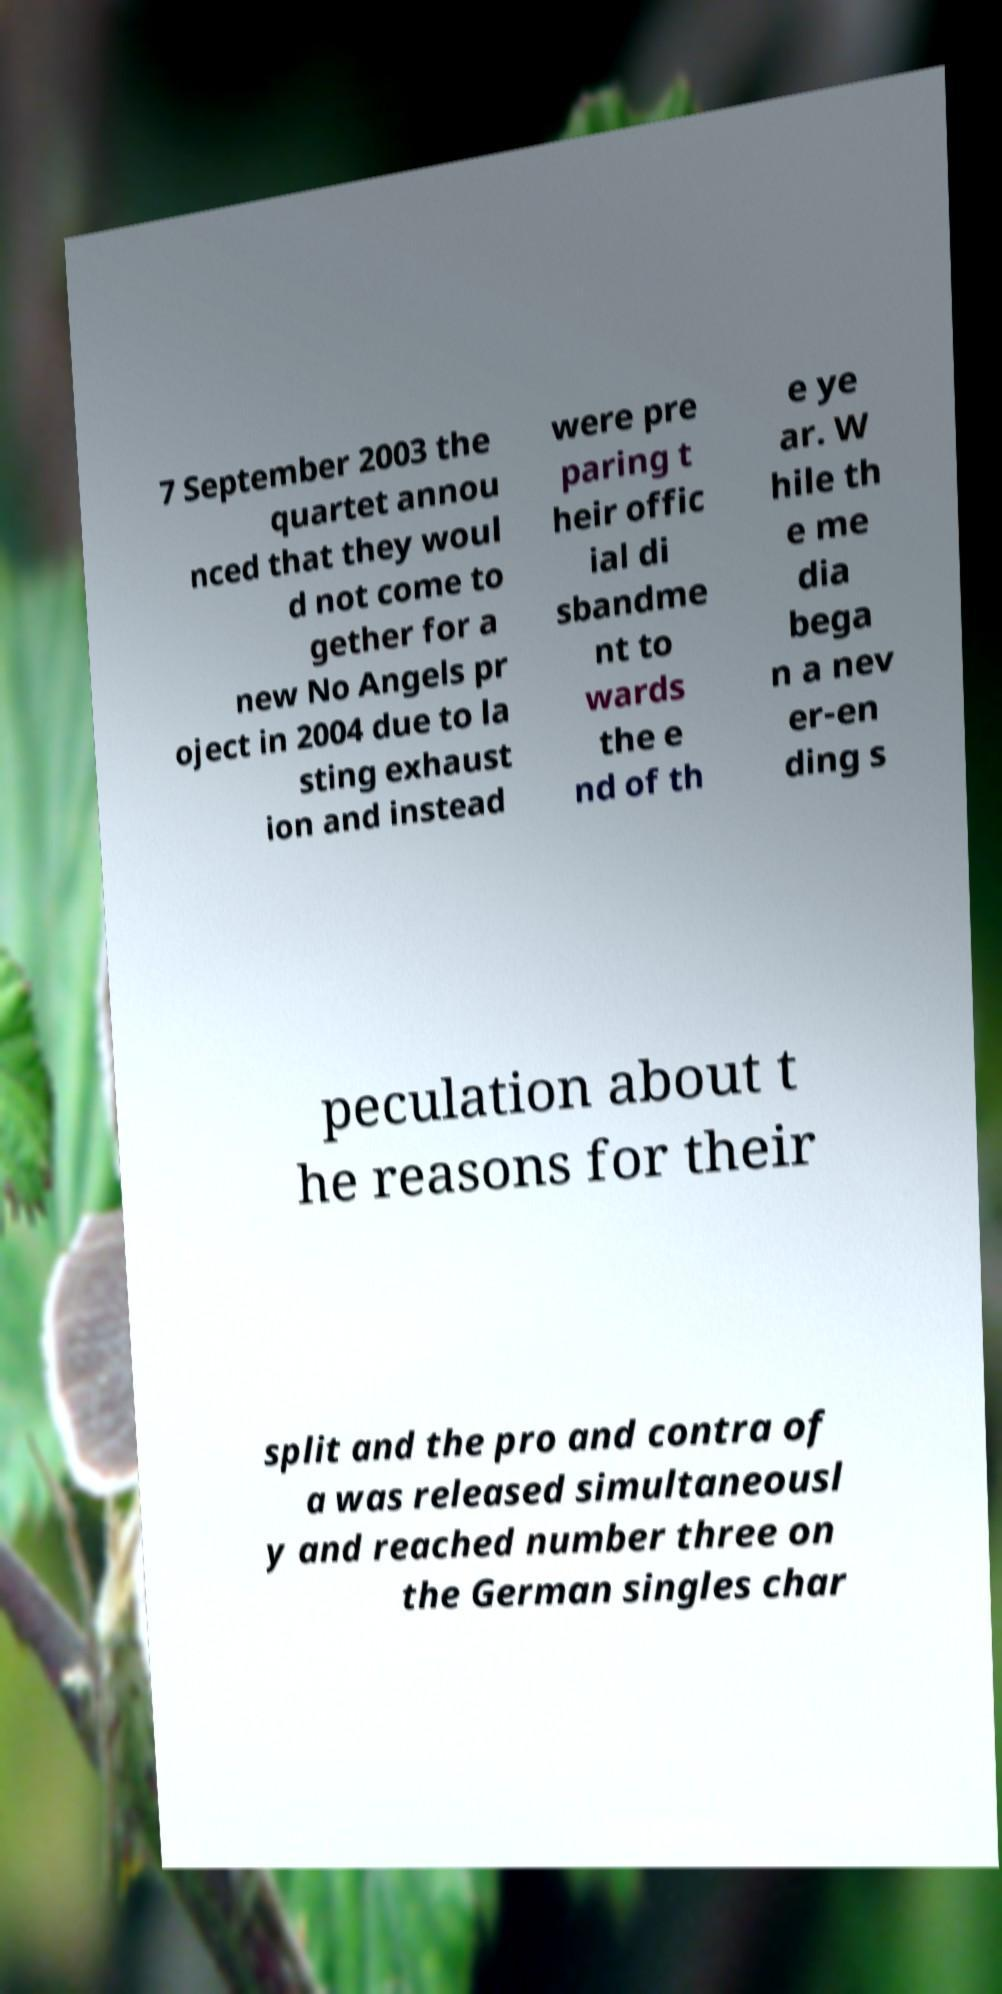I need the written content from this picture converted into text. Can you do that? 7 September 2003 the quartet annou nced that they woul d not come to gether for a new No Angels pr oject in 2004 due to la sting exhaust ion and instead were pre paring t heir offic ial di sbandme nt to wards the e nd of th e ye ar. W hile th e me dia bega n a nev er-en ding s peculation about t he reasons for their split and the pro and contra of a was released simultaneousl y and reached number three on the German singles char 